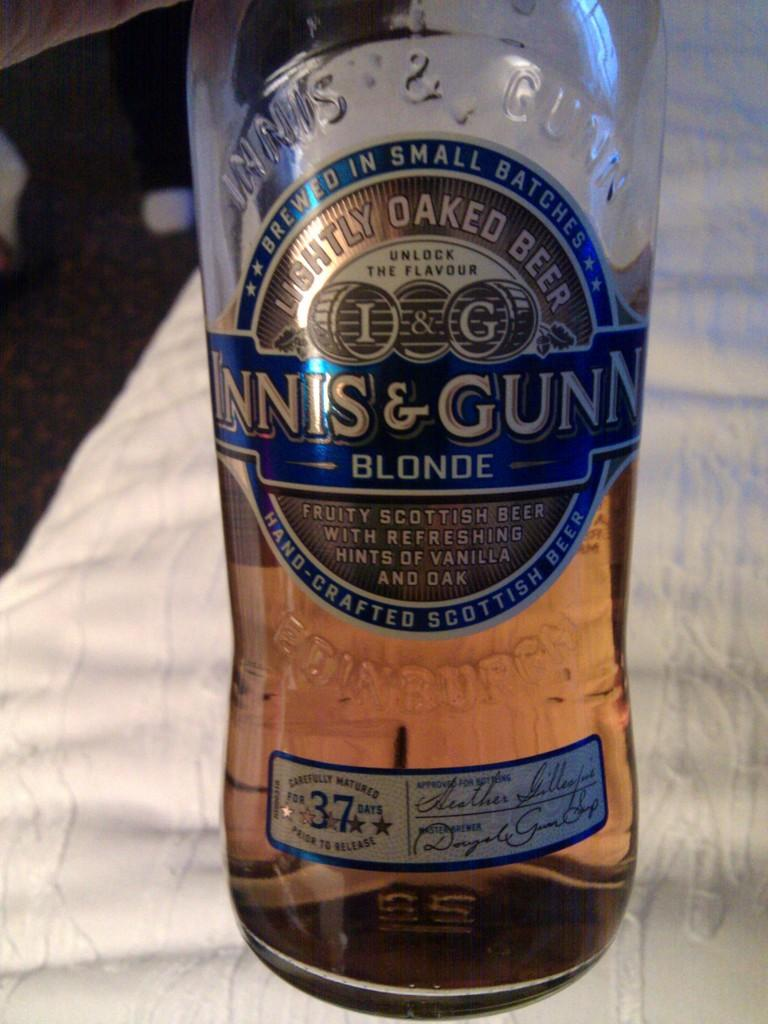<image>
Provide a brief description of the given image. Lear bottle of Innis & Gunn small batch Scottish beer brewed in Edinurg 